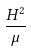<formula> <loc_0><loc_0><loc_500><loc_500>\frac { H ^ { 2 } } { \mu }</formula> 